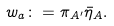Convert formula to latex. <formula><loc_0><loc_0><loc_500><loc_500>w _ { a } \colon = \pi _ { A ^ { \prime } } { \bar { \eta } } _ { A } .</formula> 